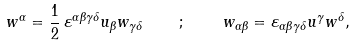Convert formula to latex. <formula><loc_0><loc_0><loc_500><loc_500>w ^ { \alpha } = \frac { 1 } { 2 } \, \varepsilon ^ { \alpha \beta \gamma \delta } u _ { \beta } w _ { \gamma \delta } \quad ; \quad w _ { \alpha \beta } = \varepsilon _ { \alpha \beta \gamma \delta } u ^ { \gamma } w ^ { \delta } ,</formula> 